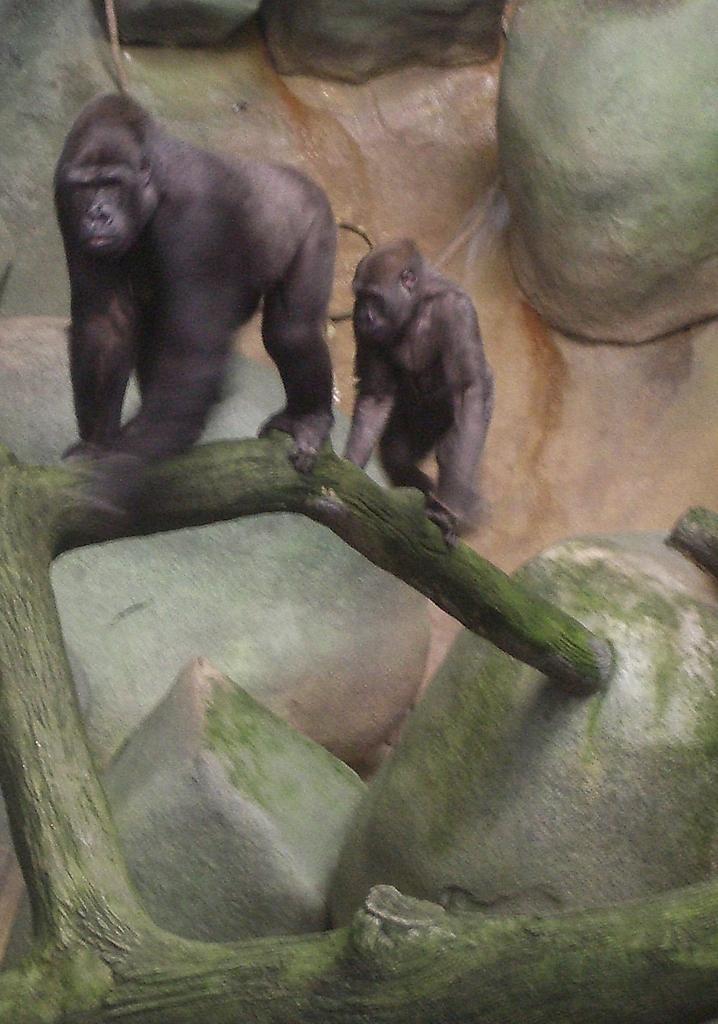How would you summarize this image in a sentence or two? In this image I can see two animals which are black in color on a tree branch and in the background I can see few huge rocks. 